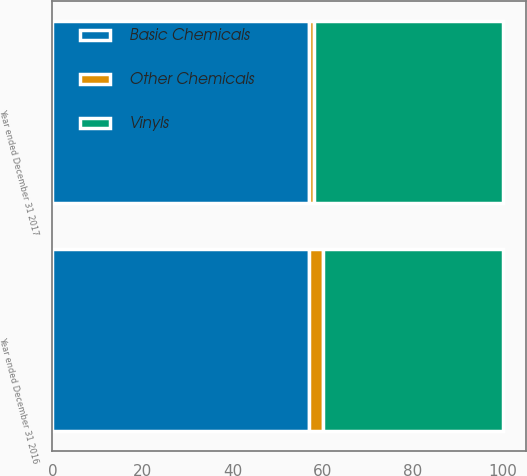<chart> <loc_0><loc_0><loc_500><loc_500><stacked_bar_chart><ecel><fcel>Year ended December 31 2017<fcel>Year ended December 31 2016<nl><fcel>Basic Chemicals<fcel>57<fcel>57<nl><fcel>Vinyls<fcel>42<fcel>40<nl><fcel>Other Chemicals<fcel>1<fcel>3<nl></chart> 